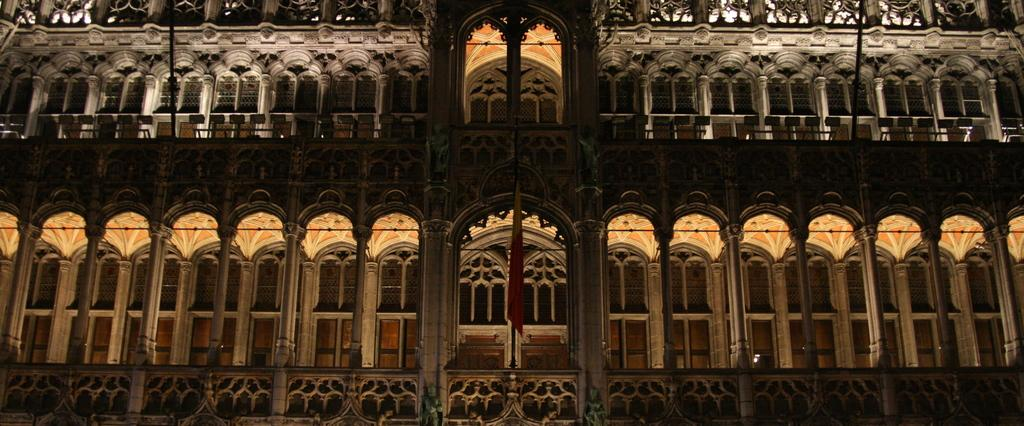At what time of day was the image taken? The image was taken during night time. What is the main subject of the image? There is a zoomed-in picture of a building in the image. Where is the flag located in the image? There is a flag in the center of the image. What type of plane can be seen taking off in the image? There is no plane visible in the image; it features a zoomed-in picture of a building with a flag in the center. How many flights are scheduled to depart from the building in the image? The image does not provide information about flights or departures from the building. 